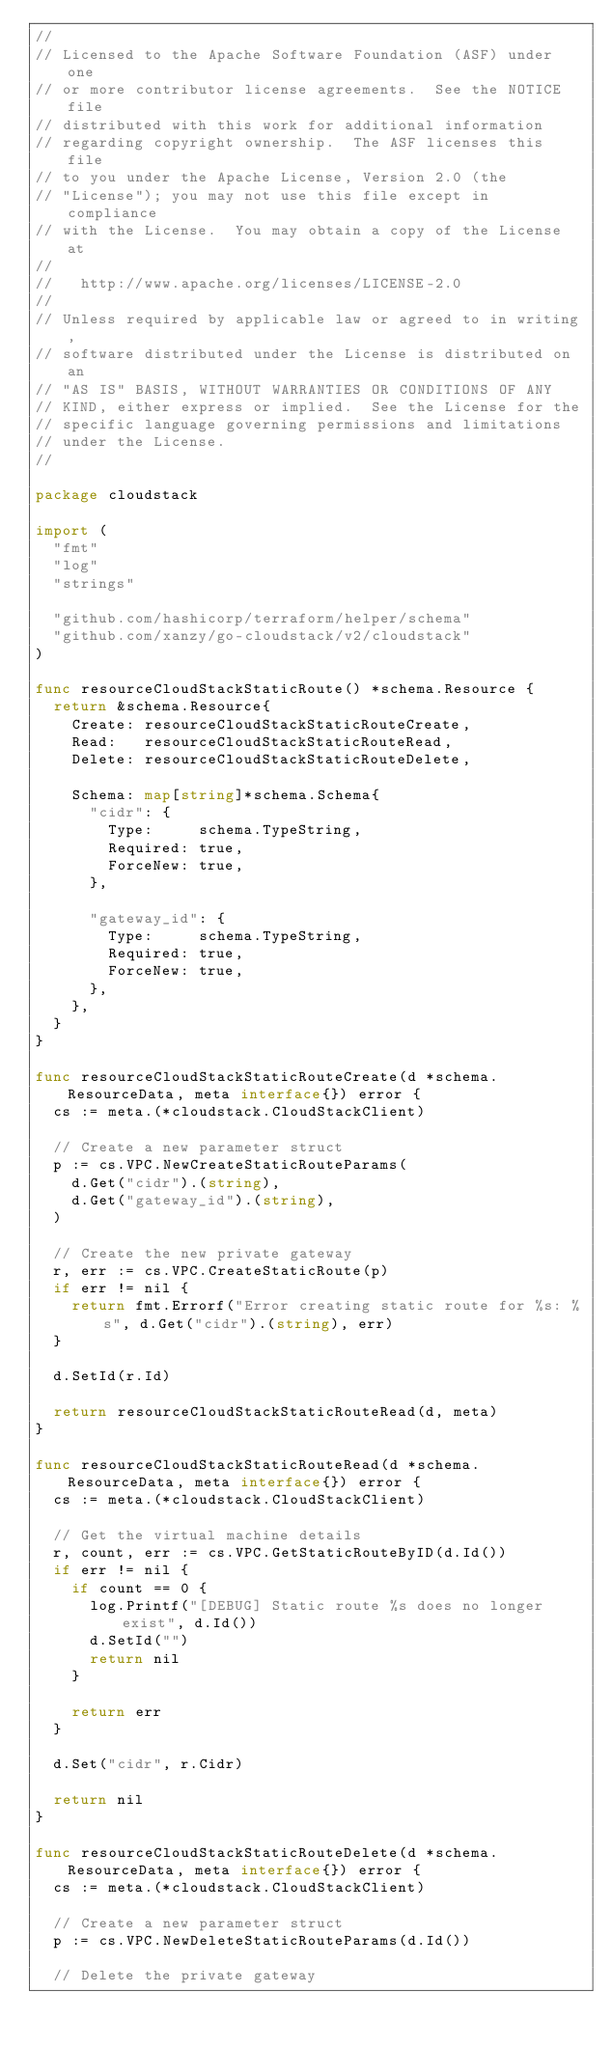Convert code to text. <code><loc_0><loc_0><loc_500><loc_500><_Go_>//
// Licensed to the Apache Software Foundation (ASF) under one
// or more contributor license agreements.  See the NOTICE file
// distributed with this work for additional information
// regarding copyright ownership.  The ASF licenses this file
// to you under the Apache License, Version 2.0 (the
// "License"); you may not use this file except in compliance
// with the License.  You may obtain a copy of the License at
//
//   http://www.apache.org/licenses/LICENSE-2.0
//
// Unless required by applicable law or agreed to in writing,
// software distributed under the License is distributed on an
// "AS IS" BASIS, WITHOUT WARRANTIES OR CONDITIONS OF ANY
// KIND, either express or implied.  See the License for the
// specific language governing permissions and limitations
// under the License.
//

package cloudstack

import (
	"fmt"
	"log"
	"strings"

	"github.com/hashicorp/terraform/helper/schema"
	"github.com/xanzy/go-cloudstack/v2/cloudstack"
)

func resourceCloudStackStaticRoute() *schema.Resource {
	return &schema.Resource{
		Create: resourceCloudStackStaticRouteCreate,
		Read:   resourceCloudStackStaticRouteRead,
		Delete: resourceCloudStackStaticRouteDelete,

		Schema: map[string]*schema.Schema{
			"cidr": {
				Type:     schema.TypeString,
				Required: true,
				ForceNew: true,
			},

			"gateway_id": {
				Type:     schema.TypeString,
				Required: true,
				ForceNew: true,
			},
		},
	}
}

func resourceCloudStackStaticRouteCreate(d *schema.ResourceData, meta interface{}) error {
	cs := meta.(*cloudstack.CloudStackClient)

	// Create a new parameter struct
	p := cs.VPC.NewCreateStaticRouteParams(
		d.Get("cidr").(string),
		d.Get("gateway_id").(string),
	)

	// Create the new private gateway
	r, err := cs.VPC.CreateStaticRoute(p)
	if err != nil {
		return fmt.Errorf("Error creating static route for %s: %s", d.Get("cidr").(string), err)
	}

	d.SetId(r.Id)

	return resourceCloudStackStaticRouteRead(d, meta)
}

func resourceCloudStackStaticRouteRead(d *schema.ResourceData, meta interface{}) error {
	cs := meta.(*cloudstack.CloudStackClient)

	// Get the virtual machine details
	r, count, err := cs.VPC.GetStaticRouteByID(d.Id())
	if err != nil {
		if count == 0 {
			log.Printf("[DEBUG] Static route %s does no longer exist", d.Id())
			d.SetId("")
			return nil
		}

		return err
	}

	d.Set("cidr", r.Cidr)

	return nil
}

func resourceCloudStackStaticRouteDelete(d *schema.ResourceData, meta interface{}) error {
	cs := meta.(*cloudstack.CloudStackClient)

	// Create a new parameter struct
	p := cs.VPC.NewDeleteStaticRouteParams(d.Id())

	// Delete the private gateway</code> 